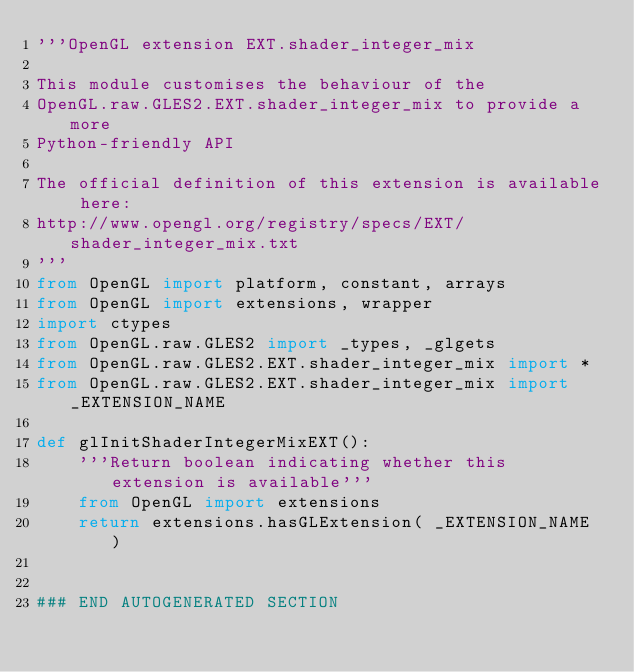<code> <loc_0><loc_0><loc_500><loc_500><_Python_>'''OpenGL extension EXT.shader_integer_mix

This module customises the behaviour of the 
OpenGL.raw.GLES2.EXT.shader_integer_mix to provide a more 
Python-friendly API

The official definition of this extension is available here:
http://www.opengl.org/registry/specs/EXT/shader_integer_mix.txt
'''
from OpenGL import platform, constant, arrays
from OpenGL import extensions, wrapper
import ctypes
from OpenGL.raw.GLES2 import _types, _glgets
from OpenGL.raw.GLES2.EXT.shader_integer_mix import *
from OpenGL.raw.GLES2.EXT.shader_integer_mix import _EXTENSION_NAME

def glInitShaderIntegerMixEXT():
    '''Return boolean indicating whether this extension is available'''
    from OpenGL import extensions
    return extensions.hasGLExtension( _EXTENSION_NAME )


### END AUTOGENERATED SECTION</code> 